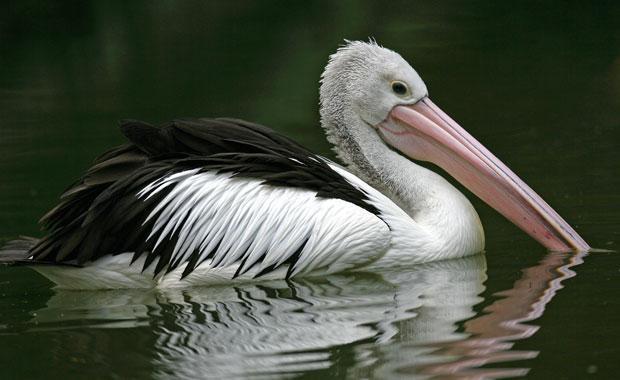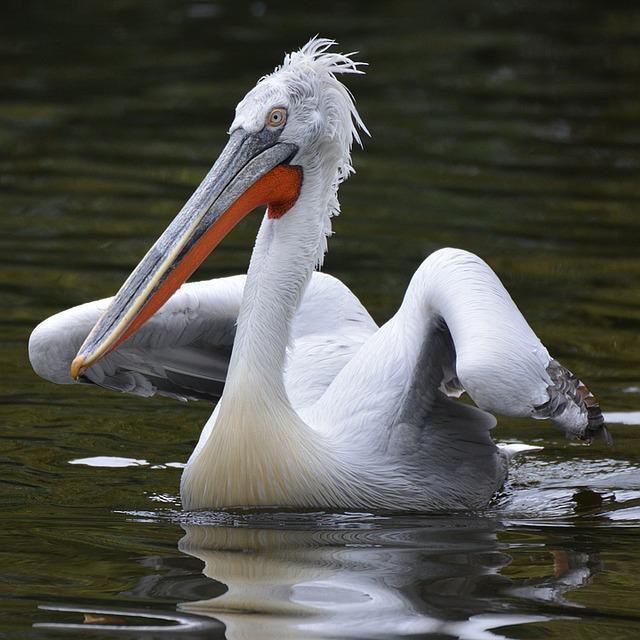The first image is the image on the left, the second image is the image on the right. Given the left and right images, does the statement "One of the images contains exactly two birds." hold true? Answer yes or no. No. 